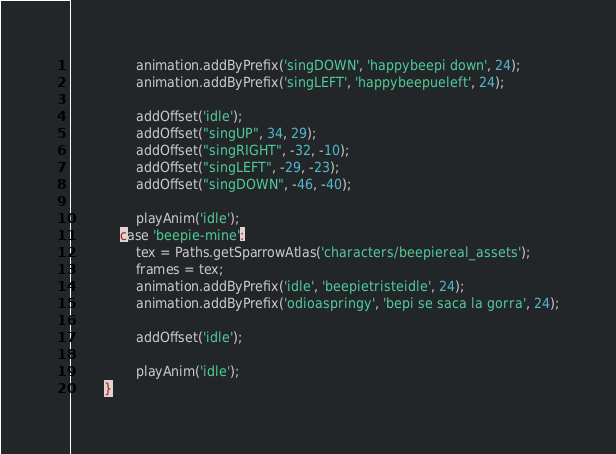Convert code to text. <code><loc_0><loc_0><loc_500><loc_500><_Haxe_>				animation.addByPrefix('singDOWN', 'happybeepi down', 24);
				animation.addByPrefix('singLEFT', 'happybeepueleft', 24);
				
				addOffset('idle');
				addOffset("singUP", 34, 29);
				addOffset("singRIGHT", -32, -10);
				addOffset("singLEFT", -29, -23);
				addOffset("singDOWN", -46, -40);
				
				playAnim('idle');
			case 'beepie-mine':
				tex = Paths.getSparrowAtlas('characters/beepiereal_assets');
				frames = tex;
				animation.addByPrefix('idle', 'beepietristeidle', 24);
				animation.addByPrefix('odioaspringy', 'bepi se saca la gorra', 24);

				addOffset('idle');

				playAnim('idle');
		}
</code> 